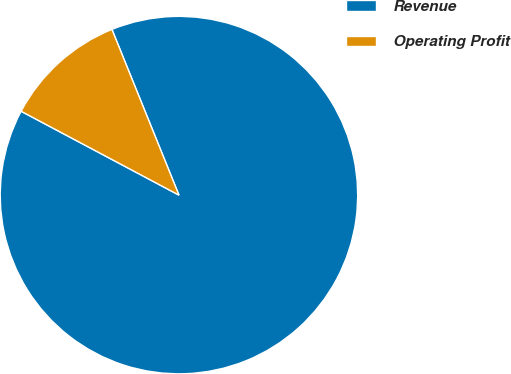<chart> <loc_0><loc_0><loc_500><loc_500><pie_chart><fcel>Revenue<fcel>Operating Profit<nl><fcel>88.89%<fcel>11.11%<nl></chart> 